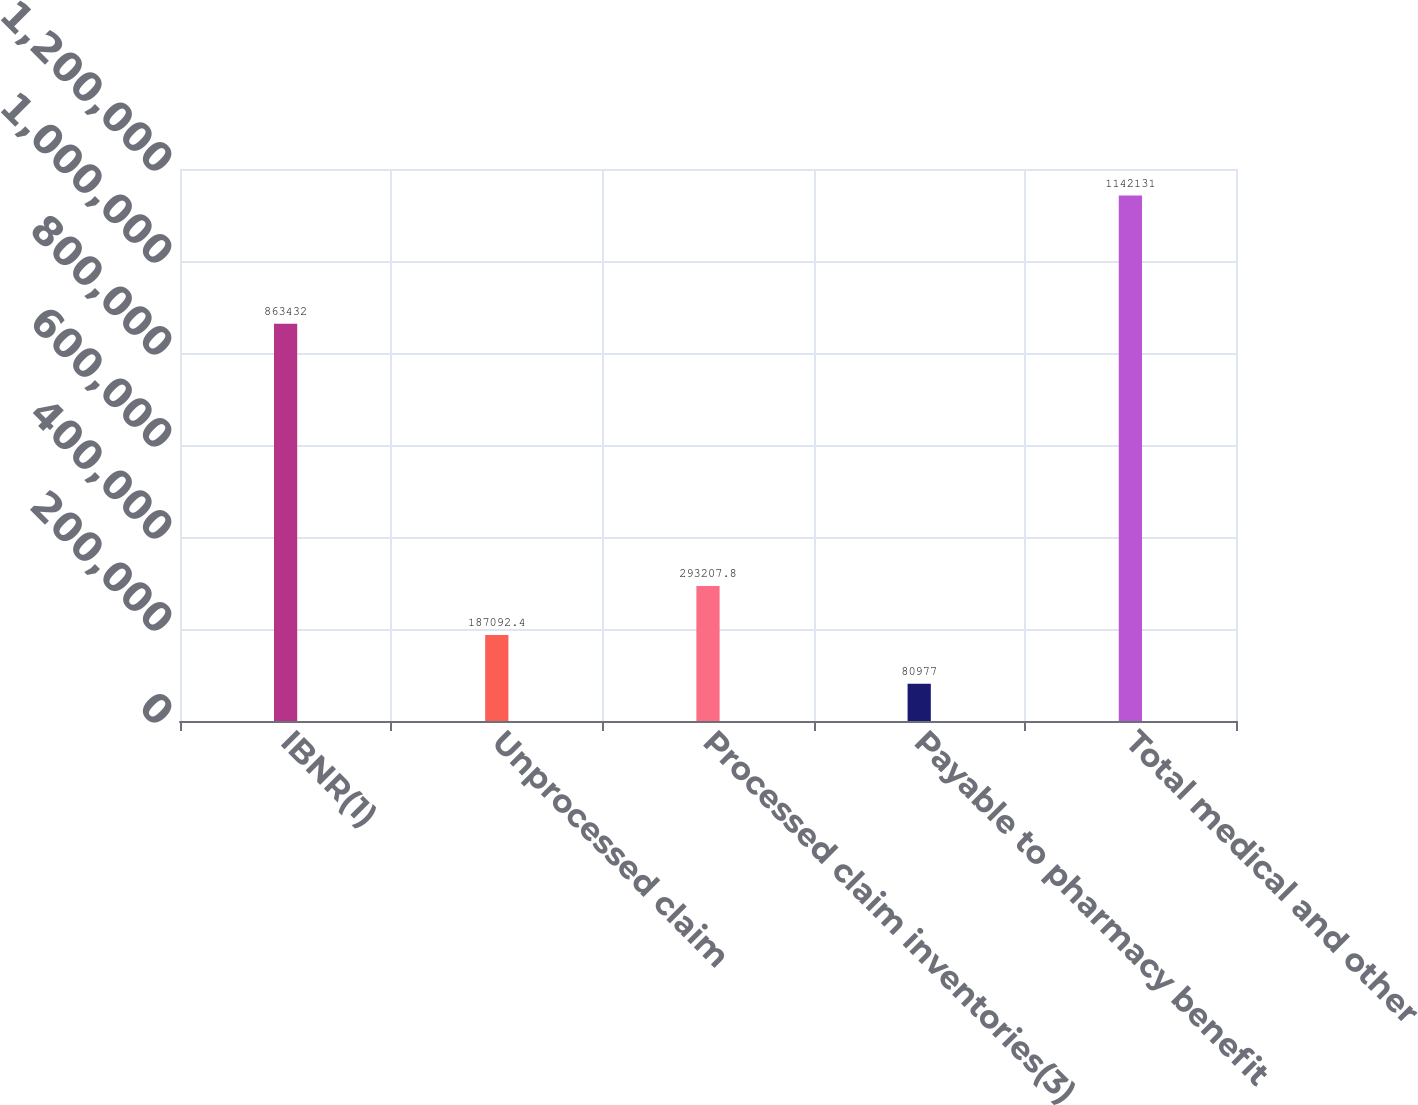Convert chart. <chart><loc_0><loc_0><loc_500><loc_500><bar_chart><fcel>IBNR(1)<fcel>Unprocessed claim<fcel>Processed claim inventories(3)<fcel>Payable to pharmacy benefit<fcel>Total medical and other<nl><fcel>863432<fcel>187092<fcel>293208<fcel>80977<fcel>1.14213e+06<nl></chart> 